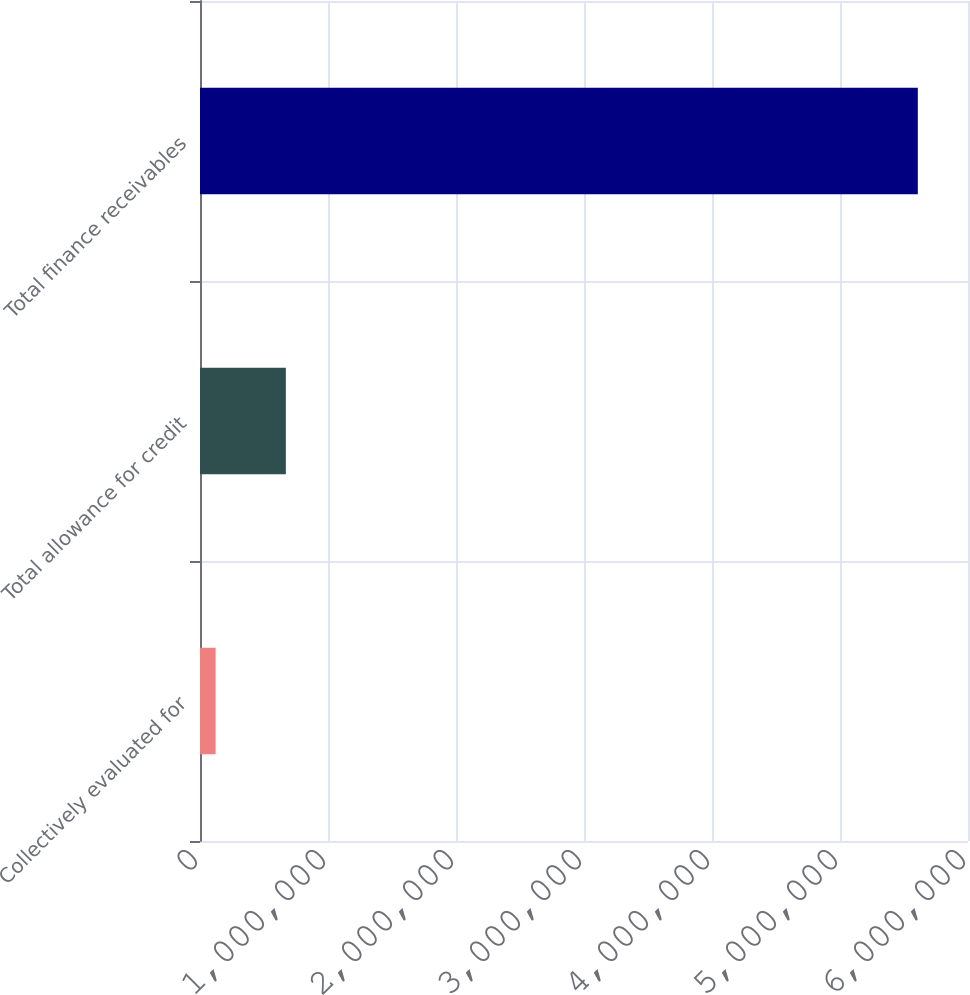Convert chart. <chart><loc_0><loc_0><loc_500><loc_500><bar_chart><fcel>Collectively evaluated for<fcel>Total allowance for credit<fcel>Total finance receivables<nl><fcel>122025<fcel>670615<fcel>5.60792e+06<nl></chart> 